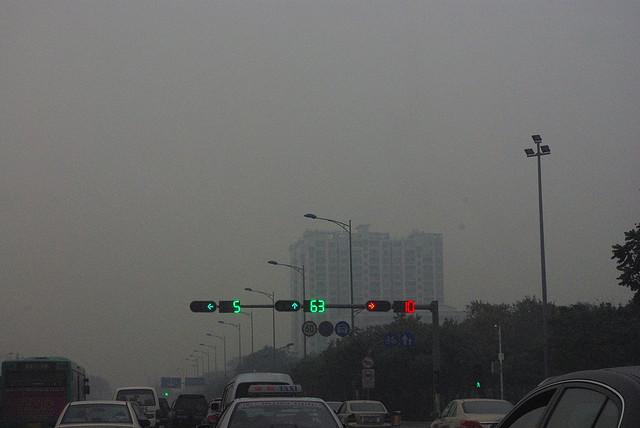How many vehicles are visible in this scene?
Answer briefly. 12. What time of day is it?
Answer briefly. Evening. What is the overcast?
Quick response, please. Sky. Should vehicles stop at this light?
Write a very short answer. No. What color is the front car?
Concise answer only. White. What is lighting up?
Give a very brief answer. Traffic lights. What color is the traffic light?
Short answer required. Green. Are these cars still sold today?
Concise answer only. Yes. Was the photo taken at night?
Quick response, please. No. What number of cars are on the road?
Be succinct. 12. Are all the numbers in green?
Give a very brief answer. No. How is the traffic light?
Be succinct. Green. Was a filter used to take this photo?
Concise answer only. No. Are the traffic lights functional (i.e., working properly) for this event?
Write a very short answer. Yes. Is it ok for left turning traffic to go now?
Write a very short answer. Yes. Sunny or overcast?
Short answer required. Overcast. How many lanes of traffic are on the left side of the median?
Write a very short answer. 4. Does the traffic signal look broken?
Quick response, please. No. Is there a reflection of a red car in this picture?
Keep it brief. No. Which object pops in color in this photo?
Concise answer only. Traffic lights. Are the street lights shining?
Quick response, please. No. How many windshields do you see?
Keep it brief. 0. Does it feel like a hazy shade of winter?
Concise answer only. Yes. What do the traffic lights say?
Short answer required. Go. Is it a cloudy day?
Concise answer only. Yes. How many lights are on each pole?
Be succinct. 3. What number is shown?
Quick response, please. 63. Is it nighttime?
Answer briefly. No. Is it day or night in this photo?
Keep it brief. Day. How many Volkswagens are visible?
Write a very short answer. 0. What kind of tower is shown in the background?
Concise answer only. Building. Is there a McDonald's?
Answer briefly. No. What color is the light?
Short answer required. Green. What time of the day is it?
Answer briefly. Dusk. What s the middle number?
Short answer required. 63. What kind of clouds are in the sky?
Write a very short answer. Storm. How many white cars are on the road?
Quick response, please. 5. Is the sky blue?
Answer briefly. No. What is far in the distance?
Concise answer only. Building. Prepare to what?
Give a very brief answer. Stop. Is this in the city?
Answer briefly. Yes. What time of day has this been taken?
Be succinct. Dusk. What kind of climate is depicted?
Write a very short answer. Foggy. How many traffic light on lite up?
Give a very brief answer. 3. How many street lights are visible?
Be succinct. 3. How many traffic lights are green in the picture?
Be succinct. 2. What vehicle is visible?
Concise answer only. Car. How many bikes are on the road?
Concise answer only. 0. Which way do the red arrows point?
Keep it brief. Right. Is there an arch in the photo?
Keep it brief. No. How many cars on the street?
Answer briefly. 9. 